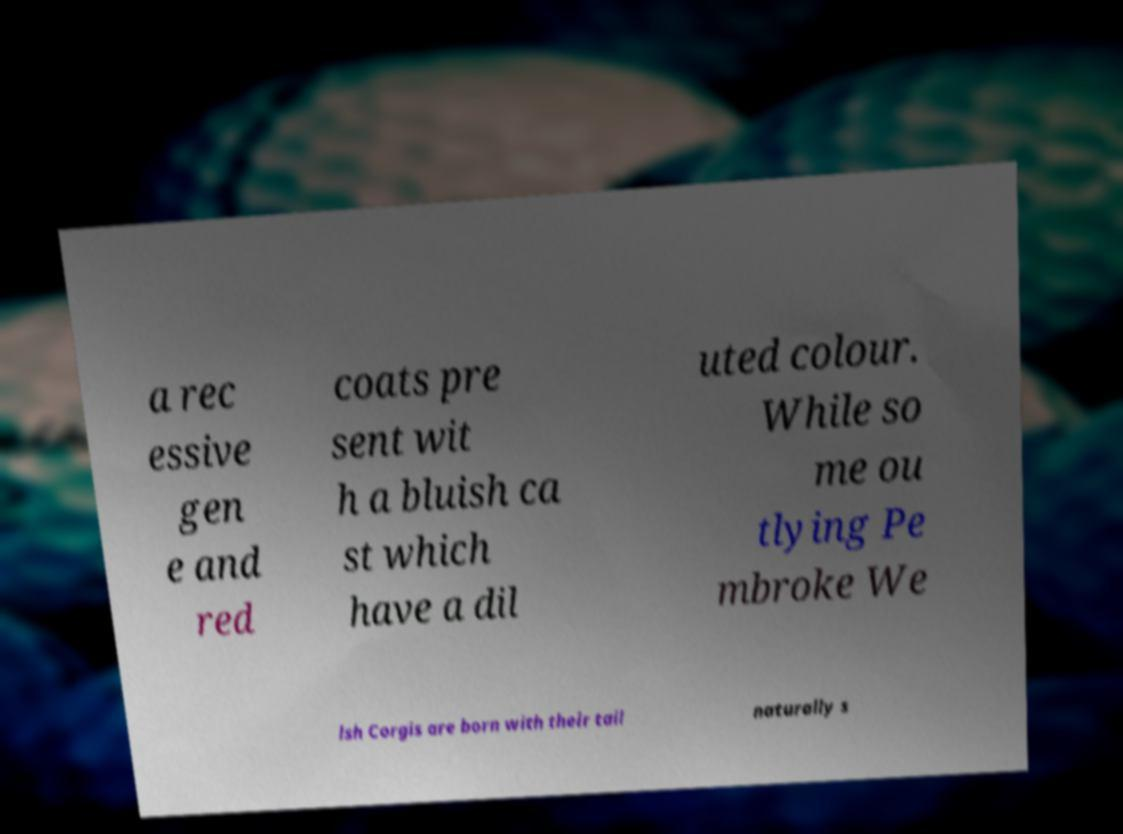Please read and relay the text visible in this image. What does it say? a rec essive gen e and red coats pre sent wit h a bluish ca st which have a dil uted colour. While so me ou tlying Pe mbroke We lsh Corgis are born with their tail naturally s 